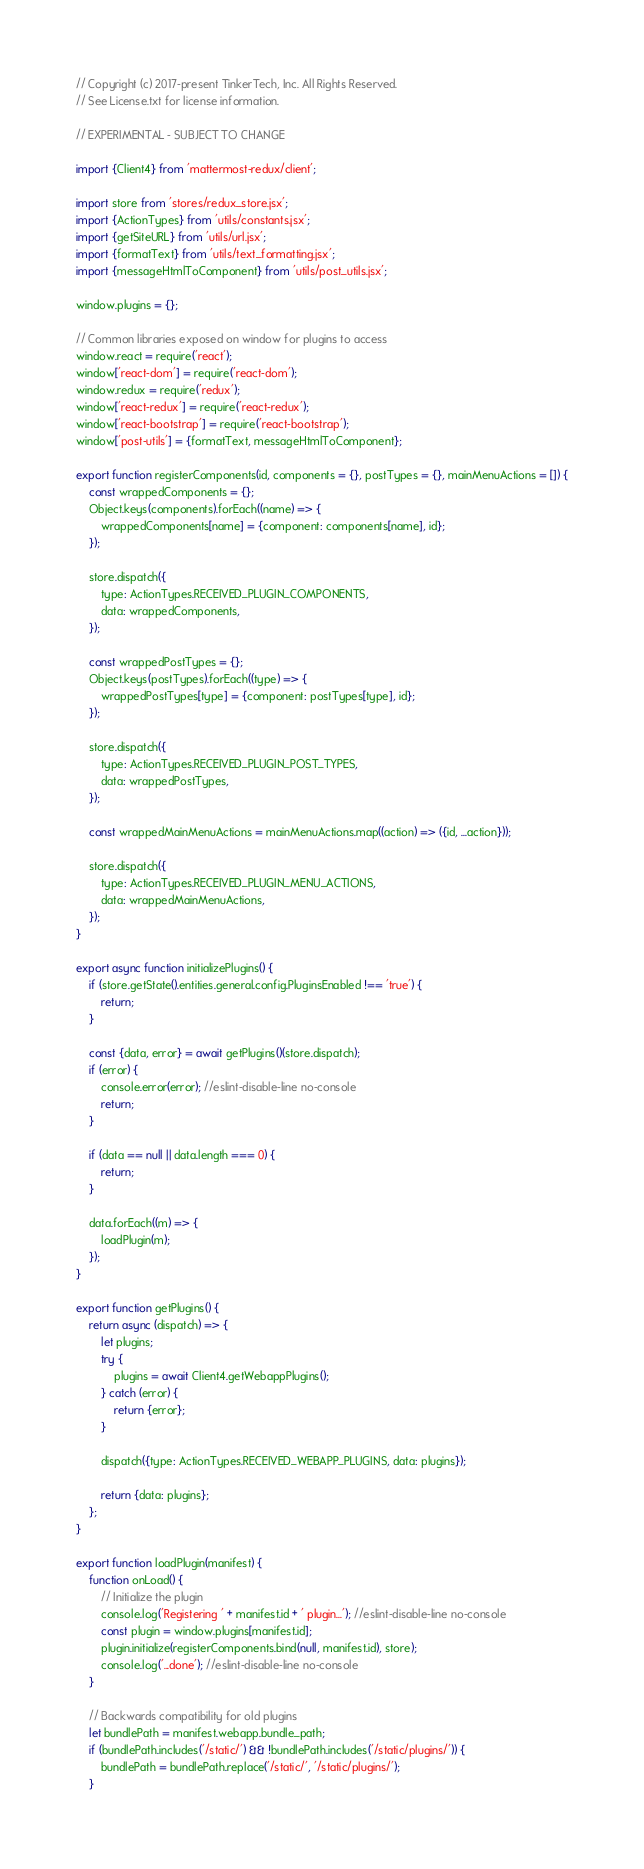Convert code to text. <code><loc_0><loc_0><loc_500><loc_500><_JavaScript_>// Copyright (c) 2017-present TinkerTech, Inc. All Rights Reserved.
// See License.txt for license information.

// EXPERIMENTAL - SUBJECT TO CHANGE

import {Client4} from 'mattermost-redux/client';

import store from 'stores/redux_store.jsx';
import {ActionTypes} from 'utils/constants.jsx';
import {getSiteURL} from 'utils/url.jsx';
import {formatText} from 'utils/text_formatting.jsx';
import {messageHtmlToComponent} from 'utils/post_utils.jsx';

window.plugins = {};

// Common libraries exposed on window for plugins to access
window.react = require('react');
window['react-dom'] = require('react-dom');
window.redux = require('redux');
window['react-redux'] = require('react-redux');
window['react-bootstrap'] = require('react-bootstrap');
window['post-utils'] = {formatText, messageHtmlToComponent};

export function registerComponents(id, components = {}, postTypes = {}, mainMenuActions = []) {
    const wrappedComponents = {};
    Object.keys(components).forEach((name) => {
        wrappedComponents[name] = {component: components[name], id};
    });

    store.dispatch({
        type: ActionTypes.RECEIVED_PLUGIN_COMPONENTS,
        data: wrappedComponents,
    });

    const wrappedPostTypes = {};
    Object.keys(postTypes).forEach((type) => {
        wrappedPostTypes[type] = {component: postTypes[type], id};
    });

    store.dispatch({
        type: ActionTypes.RECEIVED_PLUGIN_POST_TYPES,
        data: wrappedPostTypes,
    });

    const wrappedMainMenuActions = mainMenuActions.map((action) => ({id, ...action}));

    store.dispatch({
        type: ActionTypes.RECEIVED_PLUGIN_MENU_ACTIONS,
        data: wrappedMainMenuActions,
    });
}

export async function initializePlugins() {
    if (store.getState().entities.general.config.PluginsEnabled !== 'true') {
        return;
    }

    const {data, error} = await getPlugins()(store.dispatch);
    if (error) {
        console.error(error); //eslint-disable-line no-console
        return;
    }

    if (data == null || data.length === 0) {
        return;
    }

    data.forEach((m) => {
        loadPlugin(m);
    });
}

export function getPlugins() {
    return async (dispatch) => {
        let plugins;
        try {
            plugins = await Client4.getWebappPlugins();
        } catch (error) {
            return {error};
        }

        dispatch({type: ActionTypes.RECEIVED_WEBAPP_PLUGINS, data: plugins});

        return {data: plugins};
    };
}

export function loadPlugin(manifest) {
    function onLoad() {
        // Initialize the plugin
        console.log('Registering ' + manifest.id + ' plugin...'); //eslint-disable-line no-console
        const plugin = window.plugins[manifest.id];
        plugin.initialize(registerComponents.bind(null, manifest.id), store);
        console.log('...done'); //eslint-disable-line no-console
    }

    // Backwards compatibility for old plugins
    let bundlePath = manifest.webapp.bundle_path;
    if (bundlePath.includes('/static/') && !bundlePath.includes('/static/plugins/')) {
        bundlePath = bundlePath.replace('/static/', '/static/plugins/');
    }
</code> 